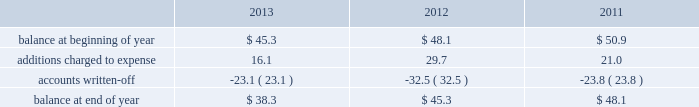Republic services , inc .
Notes to consolidated financial statements 2014 ( continued ) credit exposure , we continually monitor the credit worthiness of the financial institutions where we have deposits .
Concentrations of credit risk with respect to trade accounts receivable are limited due to the wide variety of customers and markets in which we provide services , as well as the dispersion of our operations across many geographic areas .
We provide services to commercial , industrial , municipal and residential customers in the united states and puerto rico .
We perform ongoing credit evaluations of our customers , but generally do not require collateral to support customer receivables .
We establish an allowance for doubtful accounts based on various factors including the credit risk of specific customers , age of receivables outstanding , historical trends , economic conditions and other information .
Accounts receivable , net of allowance for doubtful accounts accounts receivable represent receivables from customers for collection , transfer , recycling , disposal and other services .
Our receivables are recorded when billed or when the related revenue is earned , if earlier , and represent claims against third parties that will be settled in cash .
The carrying value of our receivables , net of the allowance for doubtful accounts , represents their estimated net realizable value .
Provisions for doubtful accounts are evaluated on a monthly basis and are recorded based on our historical collection experience , the age of the receivables , specific customer information and economic conditions .
We also review outstanding balances on an account-specific basis .
In general , reserves are provided for accounts receivable in excess of 90 days outstanding .
Past due receivable balances are written-off when our collection efforts have been unsuccessful in collecting amounts due .
The table reflects the activity in our allowance for doubtful accounts for the years ended december 31 , 2013 , 2012 and 2011: .
Restricted cash and marketable securities as of december 31 , 2013 , we had $ 169.7 million of restricted cash and marketable securities .
We obtain funds through the issuance of tax-exempt bonds for the purpose of financing qualifying expenditures at our landfills , transfer stations , collection and recycling centers .
The funds are deposited directly into trust accounts by the bonding authorities at the time of issuance .
As the use of these funds is contractually restricted , and we do not have the ability to use these funds for general operating purposes , they are classified as restricted cash and marketable securities in our consolidated balance sheets .
In the normal course of business , we may be required to provide financial assurance to governmental agencies and a variety of other entities in connection with municipal residential collection contracts , closure or post- closure of landfills , environmental remediation , environmental permits , and business licenses and permits as a financial guarantee of our performance .
At several of our landfills , we satisfy financial assurance requirements by depositing cash into restricted trust funds or escrow accounts .
Property and equipment we record property and equipment at cost .
Expenditures for major additions and improvements to facilities are capitalized , while maintenance and repairs are charged to expense as incurred .
When property is retired or .
In the account for the allowance for doubtful accounts what was the percent of the change in the additions charged to expense from 2012 to 2013? 
Rationale: the additions charged to expense in the allowance for doubtful accounts from 2012 to 2013 decreased by 46%
Computations: (16.1 - 29.7)
Answer: -13.6. Republic services , inc .
Notes to consolidated financial statements 2014 ( continued ) credit exposure , we continually monitor the credit worthiness of the financial institutions where we have deposits .
Concentrations of credit risk with respect to trade accounts receivable are limited due to the wide variety of customers and markets in which we provide services , as well as the dispersion of our operations across many geographic areas .
We provide services to commercial , industrial , municipal and residential customers in the united states and puerto rico .
We perform ongoing credit evaluations of our customers , but generally do not require collateral to support customer receivables .
We establish an allowance for doubtful accounts based on various factors including the credit risk of specific customers , age of receivables outstanding , historical trends , economic conditions and other information .
Accounts receivable , net of allowance for doubtful accounts accounts receivable represent receivables from customers for collection , transfer , recycling , disposal and other services .
Our receivables are recorded when billed or when the related revenue is earned , if earlier , and represent claims against third parties that will be settled in cash .
The carrying value of our receivables , net of the allowance for doubtful accounts , represents their estimated net realizable value .
Provisions for doubtful accounts are evaluated on a monthly basis and are recorded based on our historical collection experience , the age of the receivables , specific customer information and economic conditions .
We also review outstanding balances on an account-specific basis .
In general , reserves are provided for accounts receivable in excess of 90 days outstanding .
Past due receivable balances are written-off when our collection efforts have been unsuccessful in collecting amounts due .
The table reflects the activity in our allowance for doubtful accounts for the years ended december 31 , 2013 , 2012 and 2011: .
Restricted cash and marketable securities as of december 31 , 2013 , we had $ 169.7 million of restricted cash and marketable securities .
We obtain funds through the issuance of tax-exempt bonds for the purpose of financing qualifying expenditures at our landfills , transfer stations , collection and recycling centers .
The funds are deposited directly into trust accounts by the bonding authorities at the time of issuance .
As the use of these funds is contractually restricted , and we do not have the ability to use these funds for general operating purposes , they are classified as restricted cash and marketable securities in our consolidated balance sheets .
In the normal course of business , we may be required to provide financial assurance to governmental agencies and a variety of other entities in connection with municipal residential collection contracts , closure or post- closure of landfills , environmental remediation , environmental permits , and business licenses and permits as a financial guarantee of our performance .
At several of our landfills , we satisfy financial assurance requirements by depositing cash into restricted trust funds or escrow accounts .
Property and equipment we record property and equipment at cost .
Expenditures for major additions and improvements to facilities are capitalized , while maintenance and repairs are charged to expense as incurred .
When property is retired or .
As of december 31 , 2013 what was the ratio of the restricted cash and marketable securities to the balance in the allowance for doubtful accounts? 
Rationale: as of december 31 , 2013 there was a ratio of $ 4.43 in restricted cash and marketable securities to the balance to the balance in the allowance in doubtful accounts
Computations: (169.7 / 38.3)
Answer: 4.43081. 